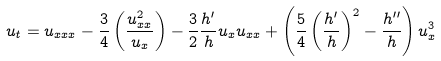<formula> <loc_0><loc_0><loc_500><loc_500>u _ { t } = u _ { x x x } - \frac { 3 } { 4 } \left ( \frac { u _ { x x } ^ { 2 } } { u _ { x } } \right ) - \frac { 3 } { 2 } \frac { h ^ { \prime } } { h } u _ { x } u _ { x x } + \left ( \frac { 5 } { 4 } \left ( \frac { h ^ { \prime } } { h } \right ) ^ { 2 } - \frac { h ^ { \prime \prime } } { h } \right ) u _ { x } ^ { 3 }</formula> 